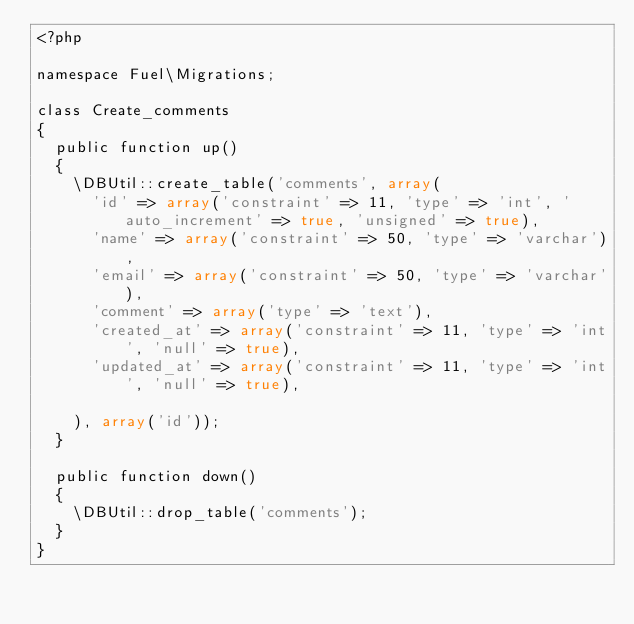<code> <loc_0><loc_0><loc_500><loc_500><_PHP_><?php

namespace Fuel\Migrations;

class Create_comments
{
	public function up()
	{
		\DBUtil::create_table('comments', array(
			'id' => array('constraint' => 11, 'type' => 'int', 'auto_increment' => true, 'unsigned' => true),
			'name' => array('constraint' => 50, 'type' => 'varchar'),
			'email' => array('constraint' => 50, 'type' => 'varchar'),
			'comment' => array('type' => 'text'),
			'created_at' => array('constraint' => 11, 'type' => 'int', 'null' => true),
			'updated_at' => array('constraint' => 11, 'type' => 'int', 'null' => true),

		), array('id'));
	}

	public function down()
	{
		\DBUtil::drop_table('comments');
	}
}</code> 